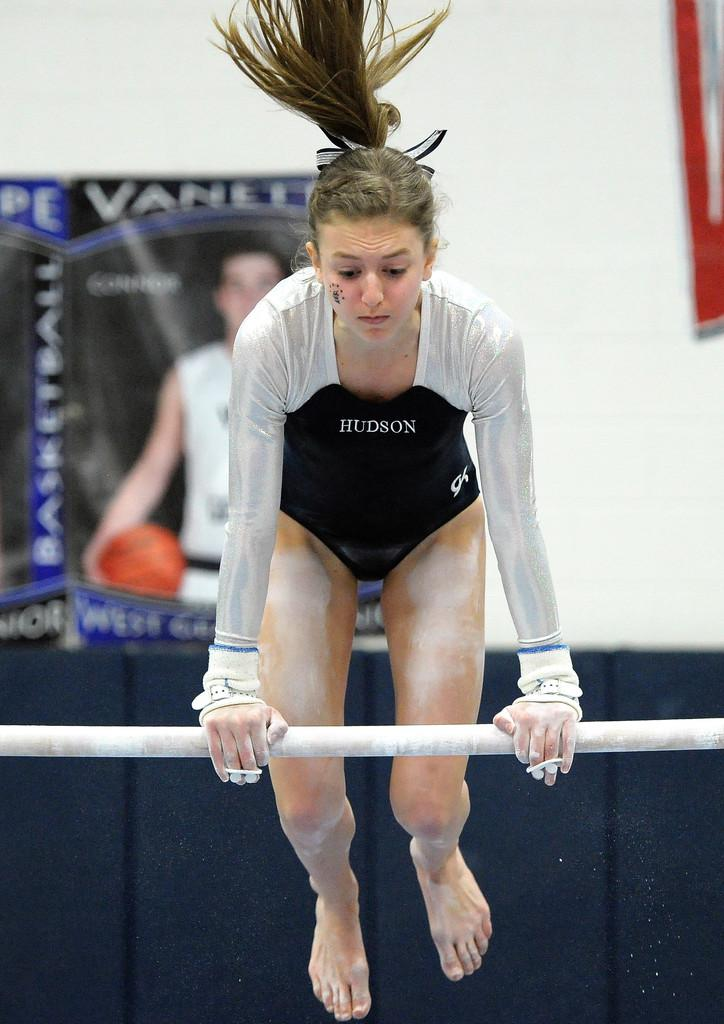Who is present in the image? There is a woman in the image. What is the woman wearing? The woman is wearing a silver color shirt. What is the woman doing in the image? The woman is jumping and holding a white color rod. What can be seen in the background of the image? There is a sheet and posters on a white wall in the background of the image. What type of teeth can be seen in the image? There are no teeth visible in the image; it features a woman jumping while holding a white color rod. 